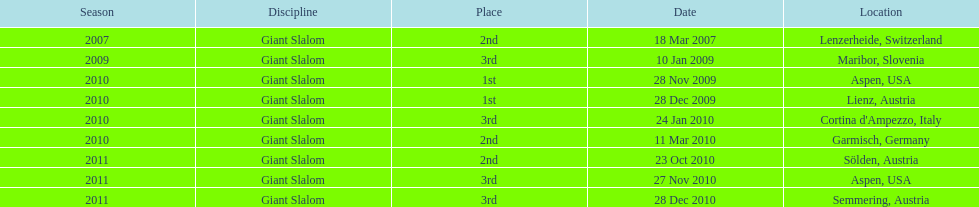What was the finishing place of the last race in december 2010? 3rd. 